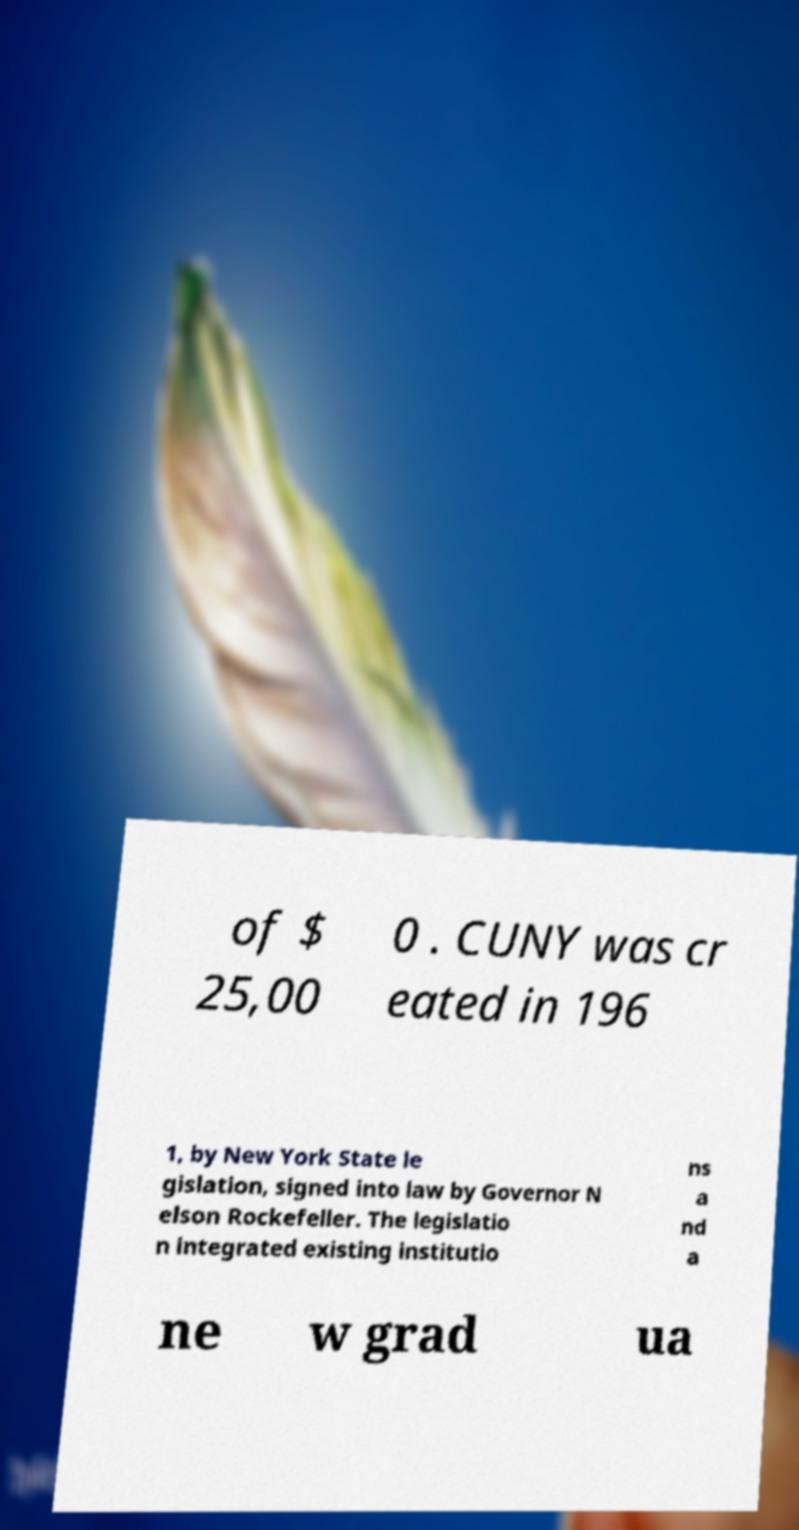Can you accurately transcribe the text from the provided image for me? of $ 25,00 0 . CUNY was cr eated in 196 1, by New York State le gislation, signed into law by Governor N elson Rockefeller. The legislatio n integrated existing institutio ns a nd a ne w grad ua 